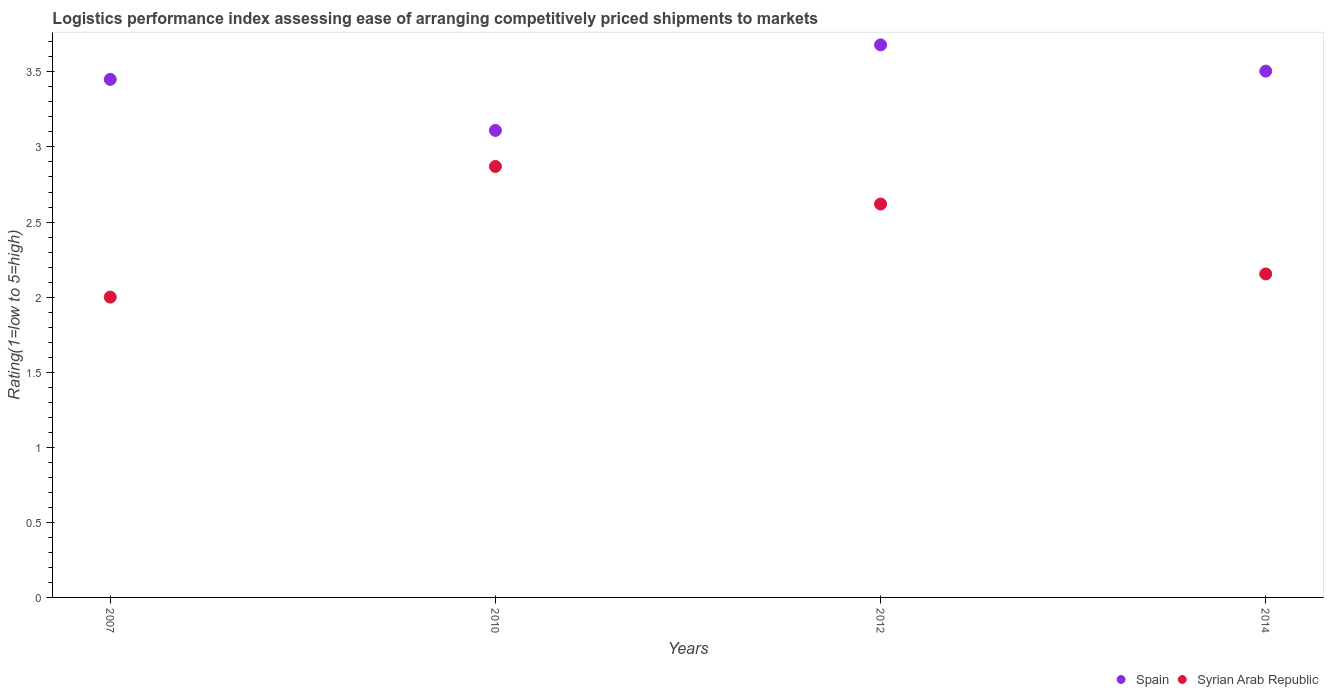What is the Logistic performance index in Spain in 2007?
Provide a succinct answer. 3.45. Across all years, what is the maximum Logistic performance index in Syrian Arab Republic?
Ensure brevity in your answer.  2.87. Across all years, what is the minimum Logistic performance index in Syrian Arab Republic?
Give a very brief answer. 2. What is the total Logistic performance index in Spain in the graph?
Provide a short and direct response. 13.75. What is the difference between the Logistic performance index in Spain in 2007 and that in 2014?
Keep it short and to the point. -0.06. What is the difference between the Logistic performance index in Spain in 2014 and the Logistic performance index in Syrian Arab Republic in 2007?
Make the answer very short. 1.51. What is the average Logistic performance index in Syrian Arab Republic per year?
Offer a very short reply. 2.41. In the year 2007, what is the difference between the Logistic performance index in Spain and Logistic performance index in Syrian Arab Republic?
Ensure brevity in your answer.  1.45. In how many years, is the Logistic performance index in Syrian Arab Republic greater than 3.6?
Offer a very short reply. 0. What is the ratio of the Logistic performance index in Syrian Arab Republic in 2010 to that in 2014?
Give a very brief answer. 1.33. Is the Logistic performance index in Spain in 2010 less than that in 2014?
Your answer should be compact. Yes. What is the difference between the highest and the second highest Logistic performance index in Syrian Arab Republic?
Offer a very short reply. 0.25. What is the difference between the highest and the lowest Logistic performance index in Spain?
Your answer should be compact. 0.57. Is the sum of the Logistic performance index in Spain in 2012 and 2014 greater than the maximum Logistic performance index in Syrian Arab Republic across all years?
Offer a very short reply. Yes. Is the Logistic performance index in Spain strictly greater than the Logistic performance index in Syrian Arab Republic over the years?
Make the answer very short. Yes. Is the Logistic performance index in Spain strictly less than the Logistic performance index in Syrian Arab Republic over the years?
Your response must be concise. No. How many dotlines are there?
Ensure brevity in your answer.  2. Does the graph contain any zero values?
Make the answer very short. No. How many legend labels are there?
Offer a terse response. 2. What is the title of the graph?
Provide a succinct answer. Logistics performance index assessing ease of arranging competitively priced shipments to markets. Does "Tuvalu" appear as one of the legend labels in the graph?
Give a very brief answer. No. What is the label or title of the X-axis?
Provide a succinct answer. Years. What is the label or title of the Y-axis?
Give a very brief answer. Rating(1=low to 5=high). What is the Rating(1=low to 5=high) of Spain in 2007?
Provide a succinct answer. 3.45. What is the Rating(1=low to 5=high) of Syrian Arab Republic in 2007?
Your answer should be compact. 2. What is the Rating(1=low to 5=high) in Spain in 2010?
Provide a short and direct response. 3.11. What is the Rating(1=low to 5=high) of Syrian Arab Republic in 2010?
Ensure brevity in your answer.  2.87. What is the Rating(1=low to 5=high) of Spain in 2012?
Your answer should be very brief. 3.68. What is the Rating(1=low to 5=high) of Syrian Arab Republic in 2012?
Ensure brevity in your answer.  2.62. What is the Rating(1=low to 5=high) in Spain in 2014?
Offer a terse response. 3.51. What is the Rating(1=low to 5=high) of Syrian Arab Republic in 2014?
Make the answer very short. 2.15. Across all years, what is the maximum Rating(1=low to 5=high) of Spain?
Provide a short and direct response. 3.68. Across all years, what is the maximum Rating(1=low to 5=high) of Syrian Arab Republic?
Offer a terse response. 2.87. Across all years, what is the minimum Rating(1=low to 5=high) of Spain?
Keep it short and to the point. 3.11. What is the total Rating(1=low to 5=high) of Spain in the graph?
Your answer should be very brief. 13.75. What is the total Rating(1=low to 5=high) in Syrian Arab Republic in the graph?
Offer a very short reply. 9.64. What is the difference between the Rating(1=low to 5=high) of Spain in 2007 and that in 2010?
Keep it short and to the point. 0.34. What is the difference between the Rating(1=low to 5=high) of Syrian Arab Republic in 2007 and that in 2010?
Offer a very short reply. -0.87. What is the difference between the Rating(1=low to 5=high) of Spain in 2007 and that in 2012?
Make the answer very short. -0.23. What is the difference between the Rating(1=low to 5=high) in Syrian Arab Republic in 2007 and that in 2012?
Ensure brevity in your answer.  -0.62. What is the difference between the Rating(1=low to 5=high) in Spain in 2007 and that in 2014?
Give a very brief answer. -0.06. What is the difference between the Rating(1=low to 5=high) of Syrian Arab Republic in 2007 and that in 2014?
Make the answer very short. -0.15. What is the difference between the Rating(1=low to 5=high) of Spain in 2010 and that in 2012?
Keep it short and to the point. -0.57. What is the difference between the Rating(1=low to 5=high) of Spain in 2010 and that in 2014?
Your answer should be compact. -0.4. What is the difference between the Rating(1=low to 5=high) in Syrian Arab Republic in 2010 and that in 2014?
Keep it short and to the point. 0.72. What is the difference between the Rating(1=low to 5=high) in Spain in 2012 and that in 2014?
Give a very brief answer. 0.17. What is the difference between the Rating(1=low to 5=high) in Syrian Arab Republic in 2012 and that in 2014?
Provide a short and direct response. 0.47. What is the difference between the Rating(1=low to 5=high) of Spain in 2007 and the Rating(1=low to 5=high) of Syrian Arab Republic in 2010?
Ensure brevity in your answer.  0.58. What is the difference between the Rating(1=low to 5=high) of Spain in 2007 and the Rating(1=low to 5=high) of Syrian Arab Republic in 2012?
Keep it short and to the point. 0.83. What is the difference between the Rating(1=low to 5=high) in Spain in 2007 and the Rating(1=low to 5=high) in Syrian Arab Republic in 2014?
Give a very brief answer. 1.3. What is the difference between the Rating(1=low to 5=high) of Spain in 2010 and the Rating(1=low to 5=high) of Syrian Arab Republic in 2012?
Your answer should be very brief. 0.49. What is the difference between the Rating(1=low to 5=high) in Spain in 2010 and the Rating(1=low to 5=high) in Syrian Arab Republic in 2014?
Offer a very short reply. 0.96. What is the difference between the Rating(1=low to 5=high) of Spain in 2012 and the Rating(1=low to 5=high) of Syrian Arab Republic in 2014?
Your answer should be compact. 1.53. What is the average Rating(1=low to 5=high) in Spain per year?
Make the answer very short. 3.44. What is the average Rating(1=low to 5=high) in Syrian Arab Republic per year?
Your answer should be very brief. 2.41. In the year 2007, what is the difference between the Rating(1=low to 5=high) in Spain and Rating(1=low to 5=high) in Syrian Arab Republic?
Offer a very short reply. 1.45. In the year 2010, what is the difference between the Rating(1=low to 5=high) in Spain and Rating(1=low to 5=high) in Syrian Arab Republic?
Give a very brief answer. 0.24. In the year 2012, what is the difference between the Rating(1=low to 5=high) of Spain and Rating(1=low to 5=high) of Syrian Arab Republic?
Make the answer very short. 1.06. In the year 2014, what is the difference between the Rating(1=low to 5=high) of Spain and Rating(1=low to 5=high) of Syrian Arab Republic?
Provide a short and direct response. 1.35. What is the ratio of the Rating(1=low to 5=high) in Spain in 2007 to that in 2010?
Keep it short and to the point. 1.11. What is the ratio of the Rating(1=low to 5=high) of Syrian Arab Republic in 2007 to that in 2010?
Offer a terse response. 0.7. What is the ratio of the Rating(1=low to 5=high) of Syrian Arab Republic in 2007 to that in 2012?
Keep it short and to the point. 0.76. What is the ratio of the Rating(1=low to 5=high) of Spain in 2007 to that in 2014?
Provide a succinct answer. 0.98. What is the ratio of the Rating(1=low to 5=high) in Syrian Arab Republic in 2007 to that in 2014?
Provide a short and direct response. 0.93. What is the ratio of the Rating(1=low to 5=high) of Spain in 2010 to that in 2012?
Ensure brevity in your answer.  0.85. What is the ratio of the Rating(1=low to 5=high) in Syrian Arab Republic in 2010 to that in 2012?
Provide a short and direct response. 1.1. What is the ratio of the Rating(1=low to 5=high) of Spain in 2010 to that in 2014?
Make the answer very short. 0.89. What is the ratio of the Rating(1=low to 5=high) of Syrian Arab Republic in 2010 to that in 2014?
Keep it short and to the point. 1.33. What is the ratio of the Rating(1=low to 5=high) in Spain in 2012 to that in 2014?
Give a very brief answer. 1.05. What is the ratio of the Rating(1=low to 5=high) in Syrian Arab Republic in 2012 to that in 2014?
Your answer should be compact. 1.22. What is the difference between the highest and the second highest Rating(1=low to 5=high) of Spain?
Give a very brief answer. 0.17. What is the difference between the highest and the second highest Rating(1=low to 5=high) in Syrian Arab Republic?
Ensure brevity in your answer.  0.25. What is the difference between the highest and the lowest Rating(1=low to 5=high) in Spain?
Make the answer very short. 0.57. What is the difference between the highest and the lowest Rating(1=low to 5=high) of Syrian Arab Republic?
Your answer should be very brief. 0.87. 